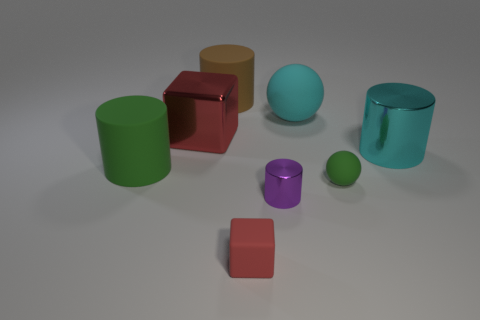What number of things are big cyan matte spheres or green balls? In the image, there is a total of one big cyan matte sphere and one green ball, making the total count two. 